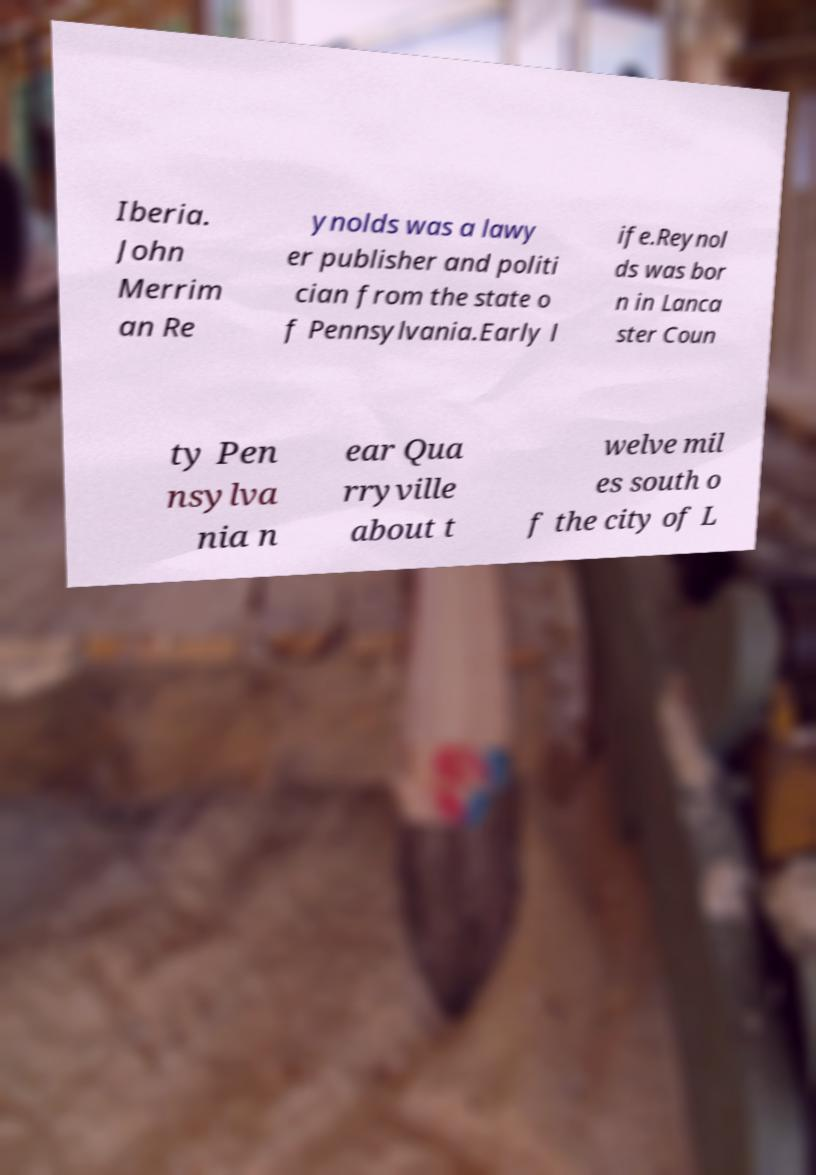Please identify and transcribe the text found in this image. Iberia. John Merrim an Re ynolds was a lawy er publisher and politi cian from the state o f Pennsylvania.Early l ife.Reynol ds was bor n in Lanca ster Coun ty Pen nsylva nia n ear Qua rryville about t welve mil es south o f the city of L 